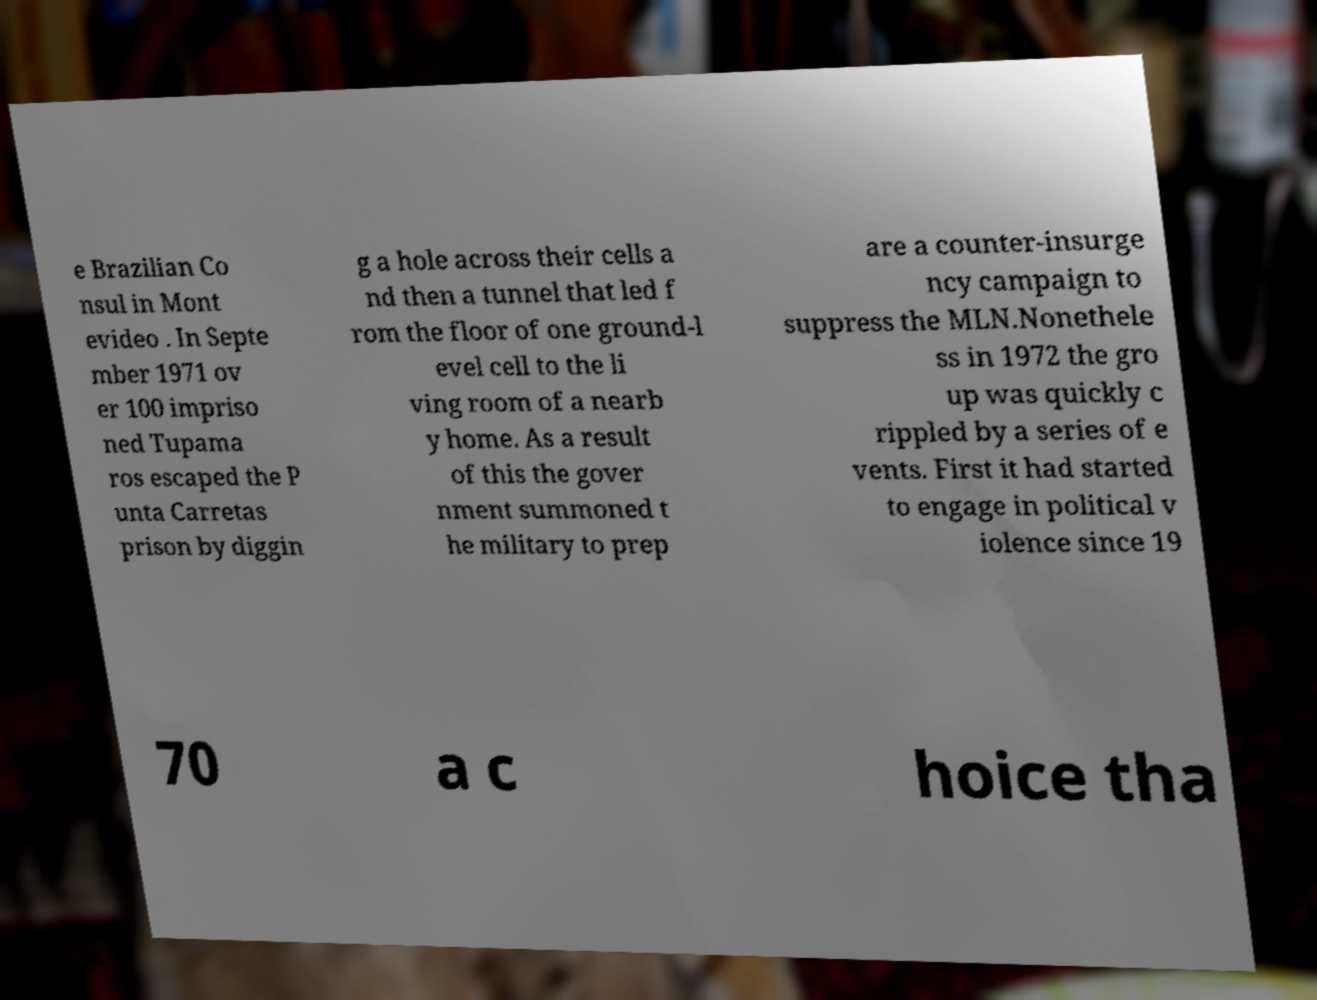There's text embedded in this image that I need extracted. Can you transcribe it verbatim? e Brazilian Co nsul in Mont evideo . In Septe mber 1971 ov er 100 impriso ned Tupama ros escaped the P unta Carretas prison by diggin g a hole across their cells a nd then a tunnel that led f rom the floor of one ground-l evel cell to the li ving room of a nearb y home. As a result of this the gover nment summoned t he military to prep are a counter-insurge ncy campaign to suppress the MLN.Nonethele ss in 1972 the gro up was quickly c rippled by a series of e vents. First it had started to engage in political v iolence since 19 70 a c hoice tha 